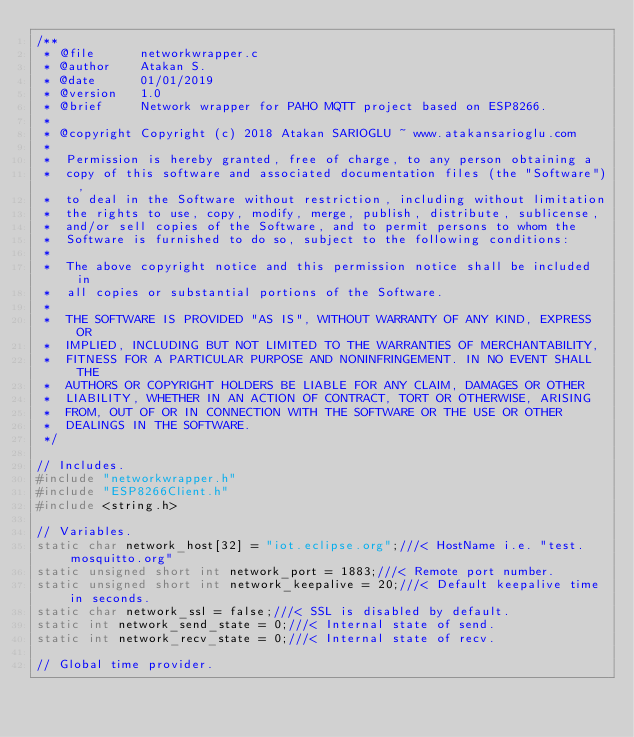Convert code to text. <code><loc_0><loc_0><loc_500><loc_500><_C_>/**
 * @file      networkwrapper.c
 * @author    Atakan S.
 * @date      01/01/2019
 * @version   1.0
 * @brief     Network wrapper for PAHO MQTT project based on ESP8266.
 *
 * @copyright Copyright (c) 2018 Atakan SARIOGLU ~ www.atakansarioglu.com
 *
 *  Permission is hereby granted, free of charge, to any person obtaining a
 *  copy of this software and associated documentation files (the "Software"),
 *  to deal in the Software without restriction, including without limitation
 *  the rights to use, copy, modify, merge, publish, distribute, sublicense,
 *  and/or sell copies of the Software, and to permit persons to whom the
 *  Software is furnished to do so, subject to the following conditions:
 *
 *  The above copyright notice and this permission notice shall be included in
 *  all copies or substantial portions of the Software.
 *
 *  THE SOFTWARE IS PROVIDED "AS IS", WITHOUT WARRANTY OF ANY KIND, EXPRESS OR
 *  IMPLIED, INCLUDING BUT NOT LIMITED TO THE WARRANTIES OF MERCHANTABILITY,
 *  FITNESS FOR A PARTICULAR PURPOSE AND NONINFRINGEMENT. IN NO EVENT SHALL THE
 *  AUTHORS OR COPYRIGHT HOLDERS BE LIABLE FOR ANY CLAIM, DAMAGES OR OTHER
 *  LIABILITY, WHETHER IN AN ACTION OF CONTRACT, TORT OR OTHERWISE, ARISING
 *  FROM, OUT OF OR IN CONNECTION WITH THE SOFTWARE OR THE USE OR OTHER
 *  DEALINGS IN THE SOFTWARE.
 */

// Includes.
#include "networkwrapper.h"
#include "ESP8266Client.h"
#include <string.h>

// Variables.
static char network_host[32] = "iot.eclipse.org";///< HostName i.e. "test.mosquitto.org"
static unsigned short int network_port = 1883;///< Remote port number.
static unsigned short int network_keepalive = 20;///< Default keepalive time in seconds.
static char network_ssl = false;///< SSL is disabled by default.
static int network_send_state = 0;///< Internal state of send.
static int network_recv_state = 0;///< Internal state of recv.

// Global time provider.</code> 